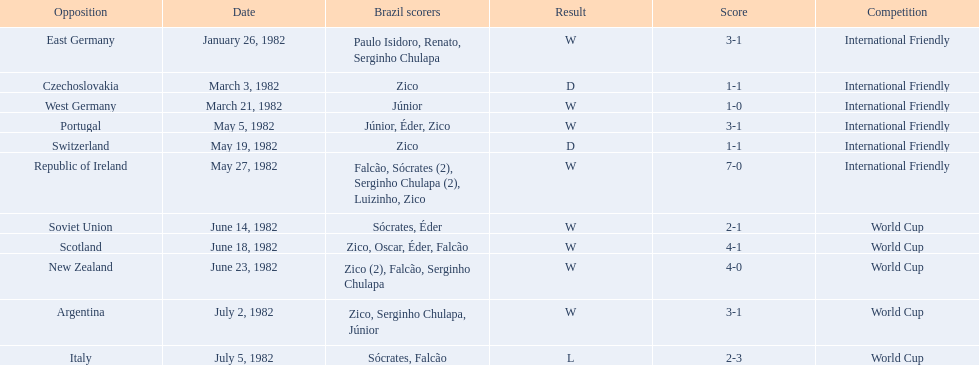What were the scores of each of game in the 1982 brazilian football games? 3-1, 1-1, 1-0, 3-1, 1-1, 7-0, 2-1, 4-1, 4-0, 3-1, 2-3. Of those, which were scores from games against portugal and the soviet union? 3-1, 2-1. And between those two games, against which country did brazil score more goals? Portugal. 